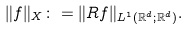<formula> <loc_0><loc_0><loc_500><loc_500>\| f \| _ { X } \colon = \| R f \| _ { L ^ { 1 } ( \mathbb { R } ^ { d } ; \mathbb { R } ^ { d } ) } .</formula> 